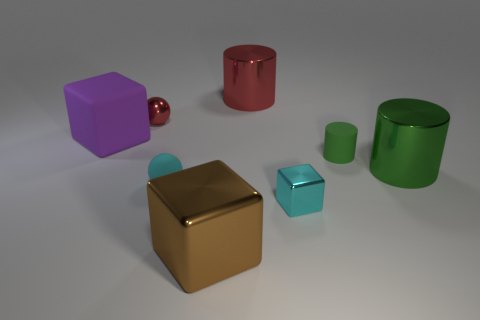Add 1 purple shiny cylinders. How many objects exist? 9 Subtract all cylinders. How many objects are left? 5 Add 2 red objects. How many red objects exist? 4 Subtract 1 cyan cubes. How many objects are left? 7 Subtract all small shiny blocks. Subtract all small brown metallic cylinders. How many objects are left? 7 Add 4 matte cylinders. How many matte cylinders are left? 5 